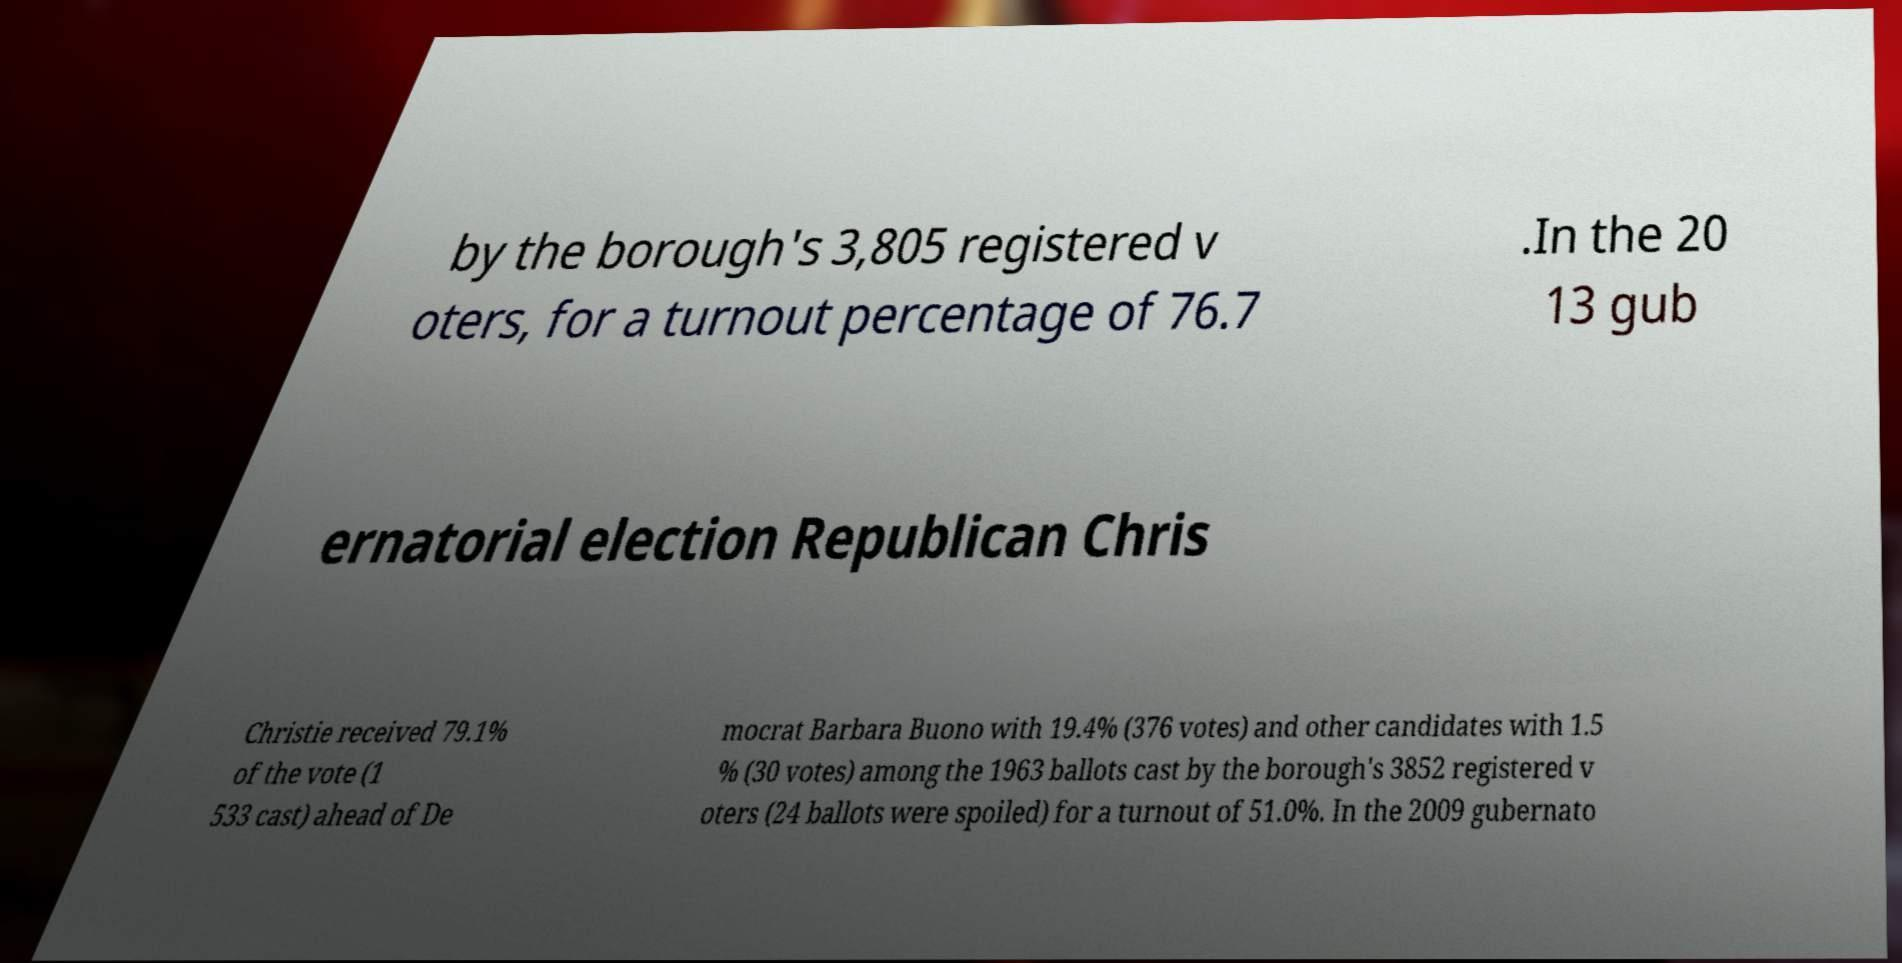For documentation purposes, I need the text within this image transcribed. Could you provide that? by the borough's 3,805 registered v oters, for a turnout percentage of 76.7 .In the 20 13 gub ernatorial election Republican Chris Christie received 79.1% of the vote (1 533 cast) ahead of De mocrat Barbara Buono with 19.4% (376 votes) and other candidates with 1.5 % (30 votes) among the 1963 ballots cast by the borough's 3852 registered v oters (24 ballots were spoiled) for a turnout of 51.0%. In the 2009 gubernato 